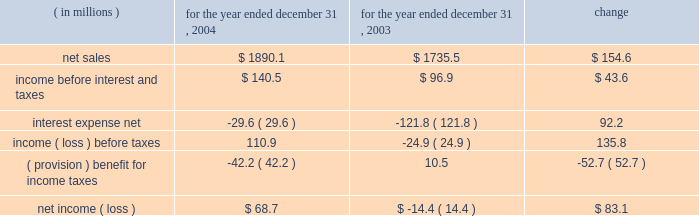Year ended december 31 , 2004 compared to year ended december 31 , 2003 the historical results of operations of pca for the years ended december 31 , 2004 and 2003 are set forth below : for the year ended december 31 , ( in millions ) 2004 2003 change .
Net sales net sales increased by $ 154.6 million , or 8.9% ( 8.9 % ) , for the year ended december 31 , 2004 from the year ended december 31 , 2003 .
Net sales increased due to improved sales volumes and prices of corrugated products and containerboard compared to 2003 .
Total corrugated products volume sold increased 6.6% ( 6.6 % ) to 29.9 billion square feet in 2004 compared to 28.1 billion square feet in 2003 .
On a comparable shipment-per-workday basis , corrugated products sales volume increased 7.0% ( 7.0 % ) in 2004 from 2003 .
Excluding pca 2019s acquisition of acorn in february 2004 , corrugated products volume was 5.3% ( 5.3 % ) higher in 2004 than 2003 and up 5.8% ( 5.8 % ) compared to 2003 on a shipment-per-workday basis .
Shipments-per-workday is calculated by dividing our total corrugated products volume during the year by the number of workdays within the year .
The larger percentage increase was due to the fact that 2004 had one less workday ( 251 days ) , those days not falling on a weekend or holiday , than 2003 ( 252 days ) .
Containerboard sales volume to external domestic and export customers increased 6.8% ( 6.8 % ) to 475000 tons for the year ended december 31 , 2004 from 445000 tons in 2003 .
Income before interest and taxes income before interest and taxes increased by $ 43.6 million , or 45.1% ( 45.1 % ) , for the year ended december 31 , 2004 compared to 2003 .
Included in income before interest and taxes for the year ended december 31 , 2004 is income of $ 27.8 million , net of expenses , attributable to a dividend paid to pca by stv , the timberlands joint venture in which pca owns a 311 20443% ( 20443 % ) ownership interest .
Included in income before interest and taxes for the year ended december 31 , 2003 is a $ 3.3 million charge for fees and expenses related to the company 2019s debt refinancing which was completed in july 2003 , and a fourth quarter charge of $ 16.0 million to settle certain benefits related matters with pactiv corporation dating back to april 12 , 1999 when pca became a stand-alone company , as described below .
During the fourth quarter of 2003 , pactiv notified pca that we owed pactiv additional amounts for hourly pension benefits and workers 2019 compensation liabilities dating back to april 12 , 1999 .
A settlement of $ 16.0 million was negotiated between pactiv and pca in december 2003 .
The full amount of the settlement was accrued in the fourth quarter of 2003 .
Excluding these special items , operating income decreased $ 3.4 million in 2004 compared to 2003 .
The $ 3.4 million decrease in income before interest and taxes was primarily attributable to increased energy and transportation costs ( $ 19.2 million ) , higher recycled and wood fiber costs ( $ 16.7 million ) , increased salary expenses related to annual increases and new hires ( $ 5.7 million ) , and increased contractual hourly labor costs ( $ 5.6 million ) , which was partially offset by increased sales volume and sales prices ( $ 44.3 million ) . .
( in millions ) for 2004 and 2003 what were total net sales? 
Computations: (1890.1 + 1735.5)
Answer: 3625.6. 